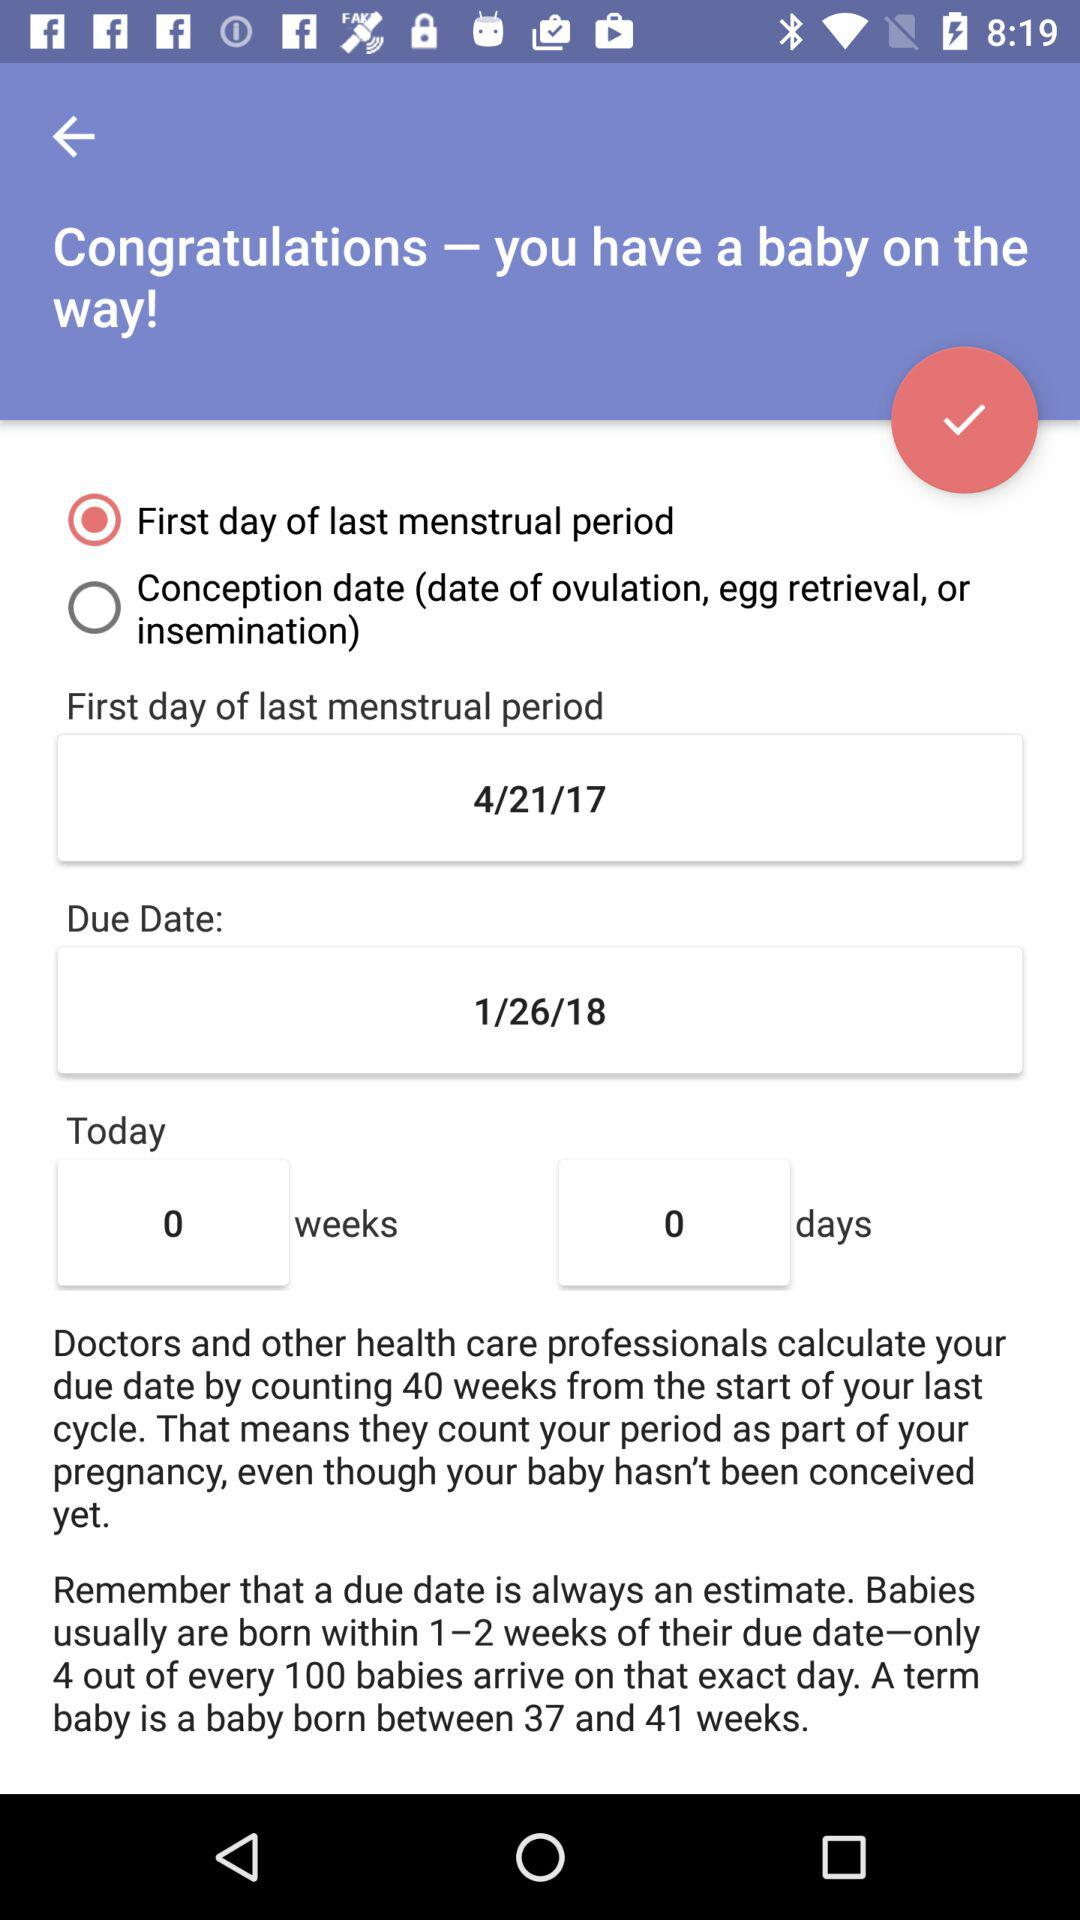What is the first day of the last menstrual period? The first day of the last menstrual period is April 21, 2017. 